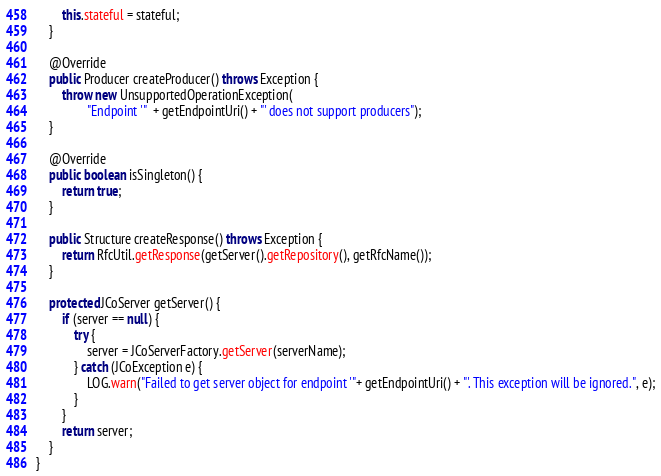Convert code to text. <code><loc_0><loc_0><loc_500><loc_500><_Java_>		this.stateful = stateful;
	}

	@Override
	public Producer createProducer() throws Exception {
		throw new UnsupportedOperationException(
				"Endpoint '"  + getEndpointUri() + "' does not support producers");
	}

	@Override
	public boolean isSingleton() {
		return true;
	}
	
	public Structure createResponse() throws Exception {
		return RfcUtil.getResponse(getServer().getRepository(), getRfcName());
	}
	
	protected JCoServer getServer() {
		if (server == null) {
			try {
				server = JCoServerFactory.getServer(serverName);
			} catch (JCoException e) {
				LOG.warn("Failed to get server object for endpoint '"+ getEndpointUri() + "'. This exception will be ignored.", e);
			}
		}
		return server;
	}
}
</code> 